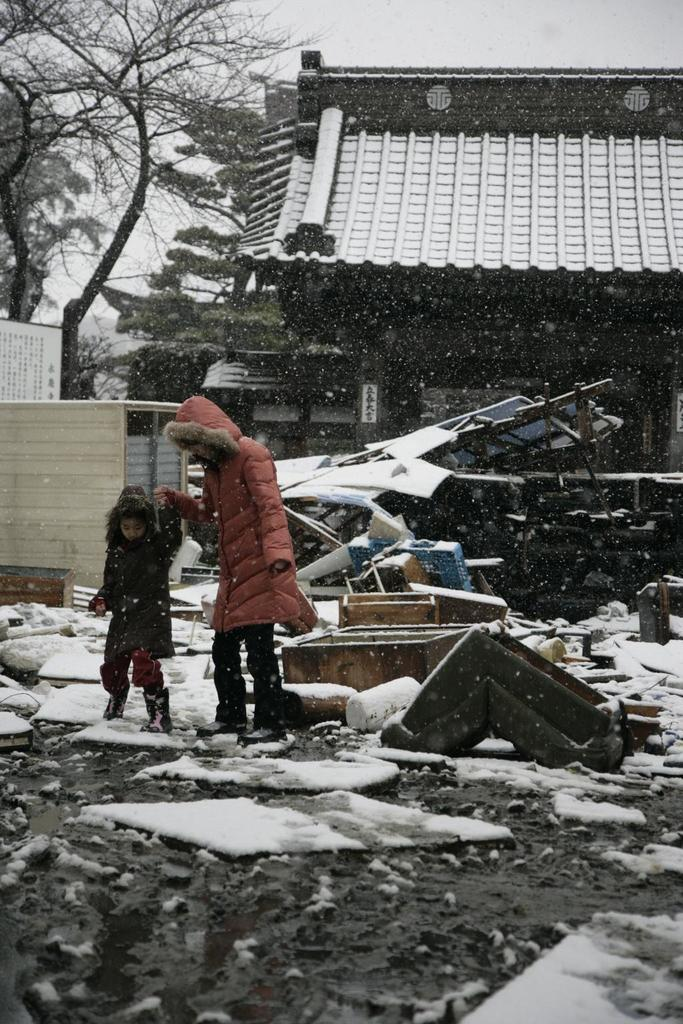What are the two persons in the image doing? The two persons in the image are walking. What can be seen in the background of the image? There are poles, buildings, and trees in the background of the image. What is visible at the top of the image? The sky is visible at the top of the image. What type of vein is visible in the image? There is no vein present in the image. What type of society is depicted in the image? The image does not depict a society; it shows two persons walking and elements in the background. 